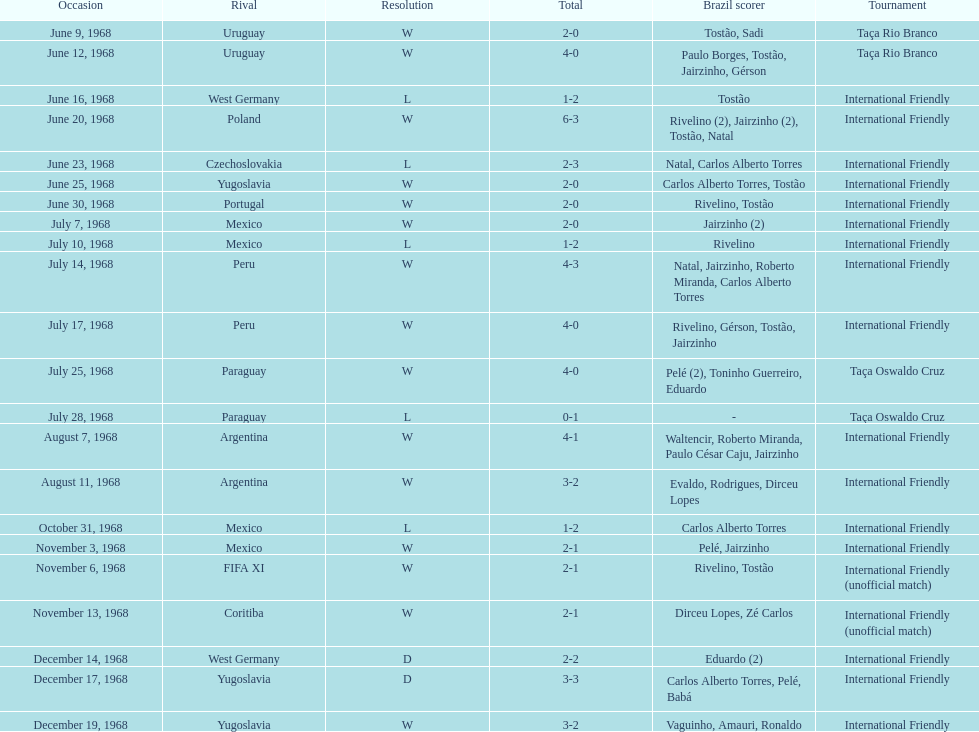Name the first competition ever played by brazil. Taça Rio Branco. 